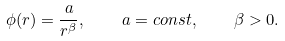<formula> <loc_0><loc_0><loc_500><loc_500>\phi ( r ) = \frac { a } { r ^ { \beta } } , \quad a = c o n s t , \quad \beta > 0 .</formula> 